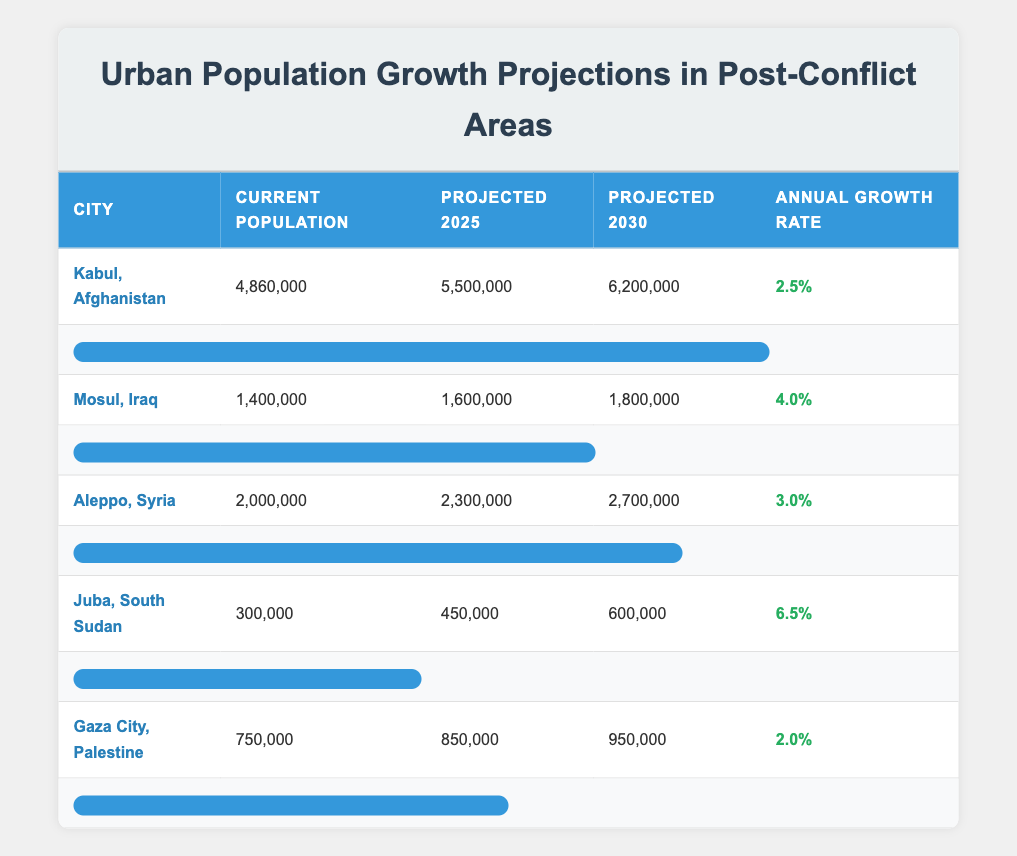What is the current population of Kabul, Afghanistan? The table directly lists the current population of Kabul, Afghanistan as 4,860,000.
Answer: 4,860,000 What is the projected population of Mosul, Iraq in 2030? The table shows that the projected population of Mosul, Iraq in 2030 is 1,800,000.
Answer: 1,800,000 Which city has the highest annual growth rate? By comparing the annual growth rates, Juba, South Sudan has the highest growth rate of 6.5%.
Answer: Juba, South Sudan What is the difference between the projected population of Aleppo, Syria in 2025 and in 2030? The projected population of Aleppo, Syria in 2025 is 2,300,000 and in 2030 is 2,700,000. The difference is 2,700,000 - 2,300,000 = 400,000.
Answer: 400,000 Is the current population of Gaza City, Palestine greater than 800,000? The current population of Gaza City, Palestine is 750,000, which is less than 800,000.
Answer: No What is the average projected population across all cities for the year 2025? The projected populations for 2025 are 5,500,000 (Kabul) + 1,600,000 (Mosul) + 2,300,000 (Aleppo) + 450,000 (Juba) + 850,000 (Gaza) = 10,650,000. There are 5 cities, so the average is 10,650,000 / 5 = 2,130,000.
Answer: 2,130,000 In which city is the growth rate lower than 3%? By checking the growth rates, both Gaza City, Palestine (2.0%) and Kabul, Afghanistan (2.5%) have growth rates lower than 3%. The response identifies both cities.
Answer: Gaza City, Palestine; Kabul, Afghanistan What is the total current population of all cities listed? The current populations are 4,860,000 (Kabul) + 1,400,000 (Mosul) + 2,000,000 (Aleppo) + 300,000 (Juba) + 750,000 (Gaza) = 9,310,000.
Answer: 9,310,000 Is the projected population growth rate for Mosul, Iraq higher than that of Kabul, Afghanistan? Mosul has a growth rate of 4.0% while Kabul has a growth rate of 2.5%, thus confirming that Mosul's growth rate is higher.
Answer: Yes 